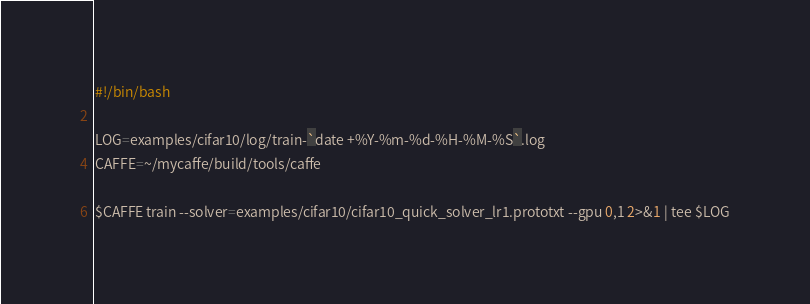<code> <loc_0><loc_0><loc_500><loc_500><_Bash_>#!/bin/bash

LOG=examples/cifar10/log/train-`date +%Y-%m-%d-%H-%M-%S`.log
CAFFE=~/mycaffe/build/tools/caffe

$CAFFE train --solver=examples/cifar10/cifar10_quick_solver_lr1.prototxt --gpu 0,1 2>&1 | tee $LOG

</code> 